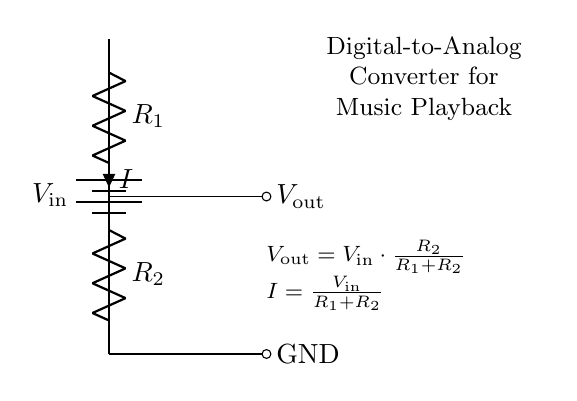What is the input voltage of this circuit? The input voltage is represented as \( V_\text{in} \) in the circuit diagram. There is no specific numerical value given, but it is a variable dependent on the external power source.
Answer: V in What are the two resistors in this voltage divider? The resistors in the voltage divider circuit are labeled as \( R_1 \) and \( R_2 \). They are connected in series, with \( R_1 \) at the top and \( R_2 \) at the bottom.
Answer: R1, R2 What does the output voltage depend on? The output voltage \( V_\text{out} \) depends on the input voltage \( V_\text{in} \) and the values of the resistors \( R_1 \) and \( R_2 \). Specifically, it is calculated using the formula \( V_\text{out} = V_\text{in} \cdot \frac{R_2}{R_1 + R_2} \).
Answer: Input voltage and resistor values What is the current through the resistors labeled as? The current through the resistors is labeled as \( I \) in the circuit. It is calculated using the total resistance of the series resistors along with the input voltage.
Answer: I What happens to the output voltage if \( R_2 \) increases? As \( R_2 \) increases, the output voltage \( V_\text{out} \) will increase as well, since \( V_\text{out} \) is directly proportional to \( R_2 \) when \( V_\text{in} \) is held constant.
Answer: Increases What is the relationship between \( I \) and \( R_1 + R_2 \)? The current \( I \) in the circuit is inversely proportional to the sum of the resistors \( R_1 + R_2 \). The formula given is \( I = \frac{V_\text{in}}{R_1 + R_2} \), indicating that an increase in total resistance results in a decrease in current.
Answer: Inversely proportional What type of circuit is this? This circuit is a voltage divider, specifically used in a digital-to-analog converter for music playback. Voltage dividers are commonly employed to produce lower voltages from a higher voltage source.
Answer: Voltage divider 